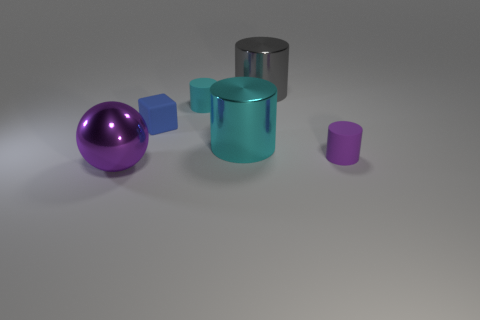There is a gray metal thing that is the same shape as the cyan matte object; what is its size?
Provide a succinct answer. Large. What number of large gray things have the same material as the small cyan cylinder?
Keep it short and to the point. 0. Are there fewer purple metallic balls behind the blue matte block than small green metal cylinders?
Give a very brief answer. No. What number of shiny cylinders are there?
Give a very brief answer. 2. How many large metallic cylinders have the same color as the tiny block?
Your answer should be very brief. 0. Is the small blue matte thing the same shape as the small cyan thing?
Offer a terse response. No. How big is the purple object in front of the small rubber cylinder right of the cyan metallic cylinder?
Your response must be concise. Large. Are there any purple rubber cylinders that have the same size as the block?
Your answer should be compact. Yes. Is the size of the purple metal thing to the left of the large gray cylinder the same as the purple object behind the big ball?
Make the answer very short. No. The shiny object in front of the purple object right of the large purple ball is what shape?
Your answer should be compact. Sphere. 